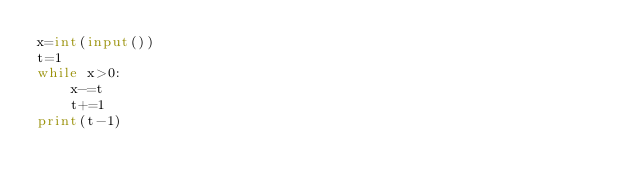<code> <loc_0><loc_0><loc_500><loc_500><_Python_>x=int(input())
t=1
while x>0:
    x-=t
    t+=1
print(t-1)</code> 